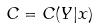<formula> <loc_0><loc_0><loc_500><loc_500>C = C ( Y | x )</formula> 